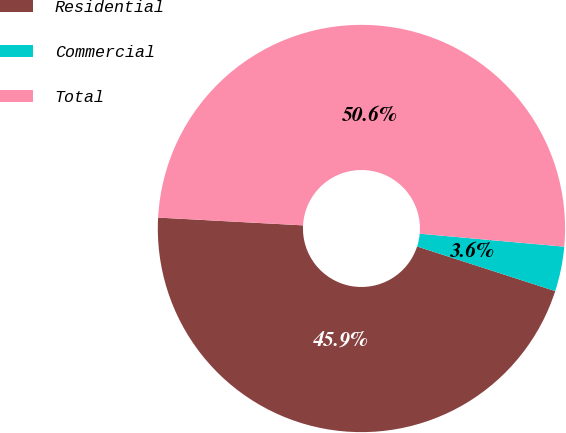Convert chart. <chart><loc_0><loc_0><loc_500><loc_500><pie_chart><fcel>Residential<fcel>Commercial<fcel>Total<nl><fcel>45.88%<fcel>3.55%<fcel>50.57%<nl></chart> 